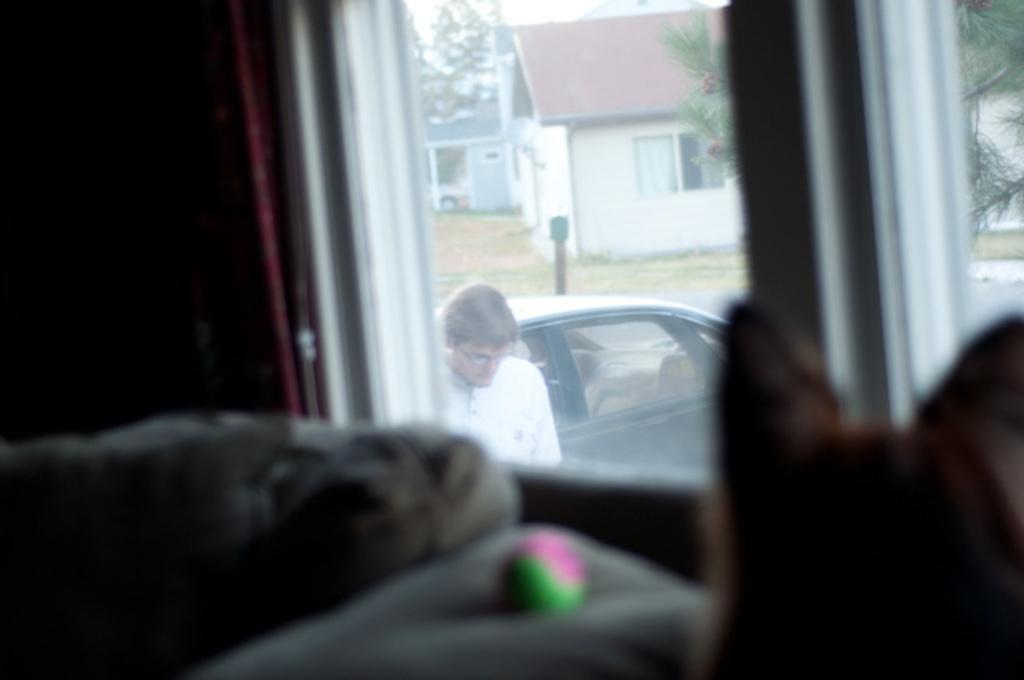What is the primary subject of the image? The image shows a window from the glass. What can be seen through the window? Houses, trees, and a car are visible through the window. Is there any indication of a person in the image? Yes, a person is wearing spectacles in the image. Are there any animals present in the image? Yes, there is a dog in the image. What other objects can be seen in the image? There is a ball in the image. What type of window treatment is present in the image? There is a curtain in the image. How many kittens are playing with the ball in the image? There are no kittens present in the image; only a dog is visible. What type of operation is being performed on the giant in the image? There is no giant or operation present in the image. 